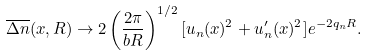Convert formula to latex. <formula><loc_0><loc_0><loc_500><loc_500>\overline { \Delta n } ( x , R ) \rightarrow 2 \left ( \frac { 2 \pi } { b R } \right ) ^ { 1 / 2 } [ u _ { n } ( x ) ^ { 2 } + u _ { n } ^ { \prime } ( x ) ^ { 2 } ] e ^ { - 2 q _ { n } R } .</formula> 